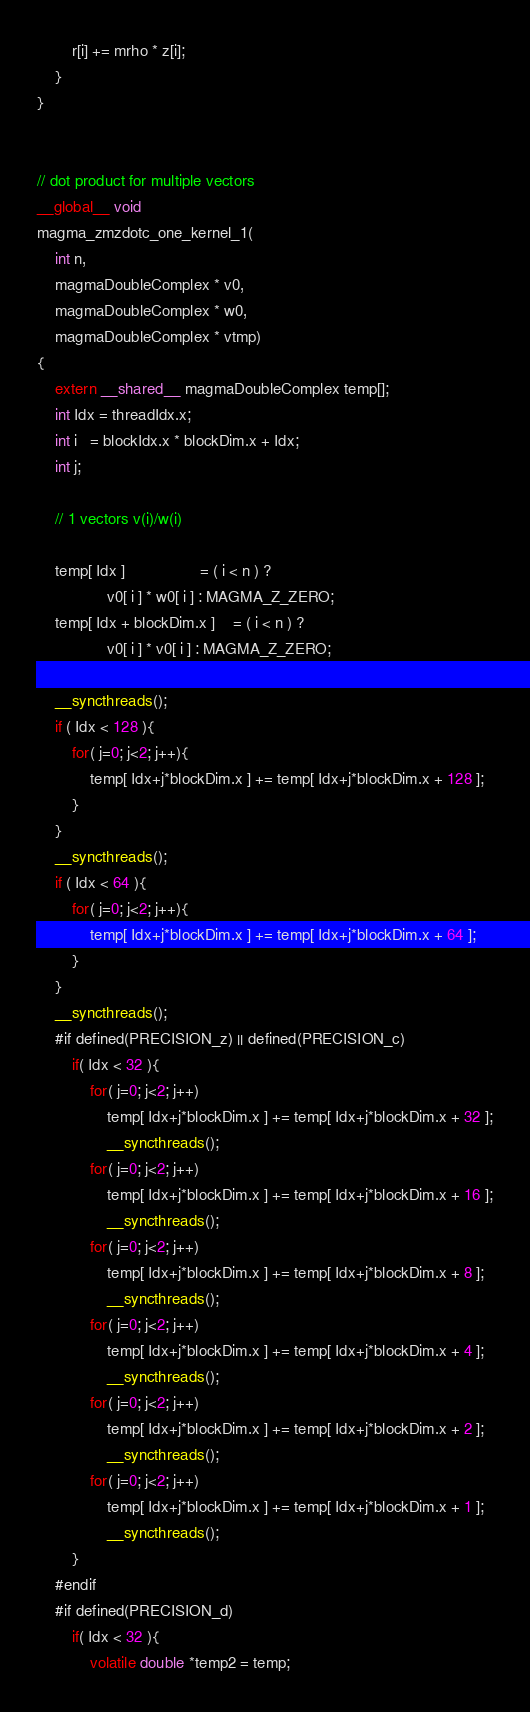<code> <loc_0><loc_0><loc_500><loc_500><_Cuda_>        r[i] += mrho * z[i];
    }
}


// dot product for multiple vectors
__global__ void
magma_zmzdotc_one_kernel_1( 
    int n, 
    magmaDoubleComplex * v0,
    magmaDoubleComplex * w0,
    magmaDoubleComplex * vtmp)
{
    extern __shared__ magmaDoubleComplex temp[]; 
    int Idx = threadIdx.x;   
    int i   = blockIdx.x * blockDim.x + Idx;
    int j;

    // 1 vectors v(i)/w(i)
    
    temp[ Idx ]                 = ( i < n ) ?
                v0[ i ] * w0[ i ] : MAGMA_Z_ZERO;
    temp[ Idx + blockDim.x ]    = ( i < n ) ?
                v0[ i ] * v0[ i ] : MAGMA_Z_ZERO;
    
    __syncthreads();
    if ( Idx < 128 ){
        for( j=0; j<2; j++){
            temp[ Idx+j*blockDim.x ] += temp[ Idx+j*blockDim.x + 128 ];
        }
    }
    __syncthreads();
    if ( Idx < 64 ){
        for( j=0; j<2; j++){
            temp[ Idx+j*blockDim.x ] += temp[ Idx+j*blockDim.x + 64 ];
        }
    }
    __syncthreads();
    #if defined(PRECISION_z) || defined(PRECISION_c)
        if( Idx < 32 ){
            for( j=0; j<2; j++)
                temp[ Idx+j*blockDim.x ] += temp[ Idx+j*blockDim.x + 32 ];
                __syncthreads();
            for( j=0; j<2; j++)
                temp[ Idx+j*blockDim.x ] += temp[ Idx+j*blockDim.x + 16 ];
                __syncthreads();
            for( j=0; j<2; j++)
                temp[ Idx+j*blockDim.x ] += temp[ Idx+j*blockDim.x + 8 ];
                __syncthreads();
            for( j=0; j<2; j++)
                temp[ Idx+j*blockDim.x ] += temp[ Idx+j*blockDim.x + 4 ];
                __syncthreads();
            for( j=0; j<2; j++)
                temp[ Idx+j*blockDim.x ] += temp[ Idx+j*blockDim.x + 2 ];
                __syncthreads();
            for( j=0; j<2; j++)
                temp[ Idx+j*blockDim.x ] += temp[ Idx+j*blockDim.x + 1 ];
                __syncthreads();
        }
    #endif
    #if defined(PRECISION_d)
        if( Idx < 32 ){
            volatile double *temp2 = temp;</code> 